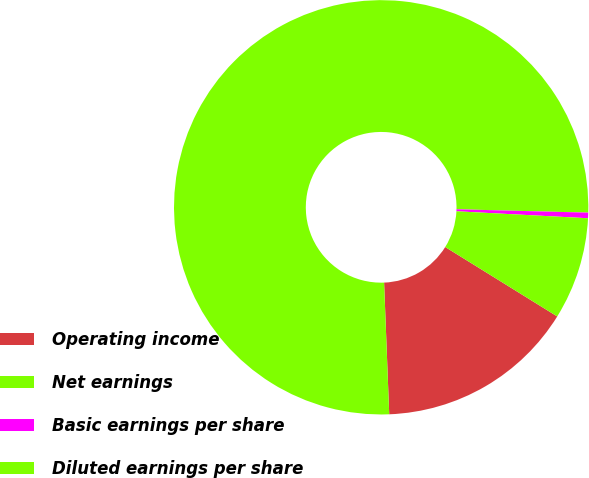Convert chart. <chart><loc_0><loc_0><loc_500><loc_500><pie_chart><fcel>Operating income<fcel>Net earnings<fcel>Basic earnings per share<fcel>Diluted earnings per share<nl><fcel>15.55%<fcel>76.03%<fcel>0.43%<fcel>7.99%<nl></chart> 